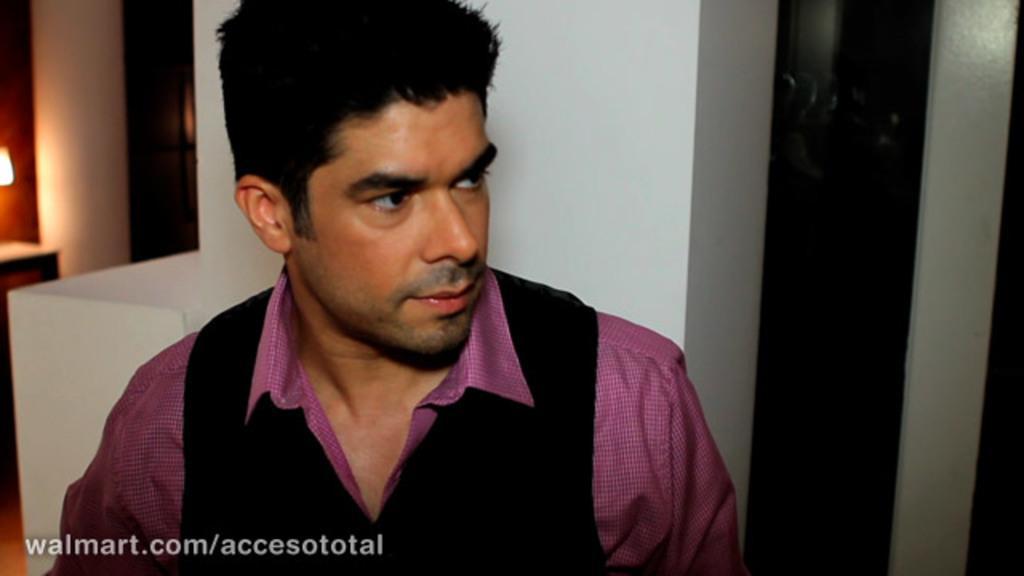How would you summarize this image in a sentence or two? In the image there is a man in purple shirt and brown vase coat standing in front of the wall with a light on the left side. 